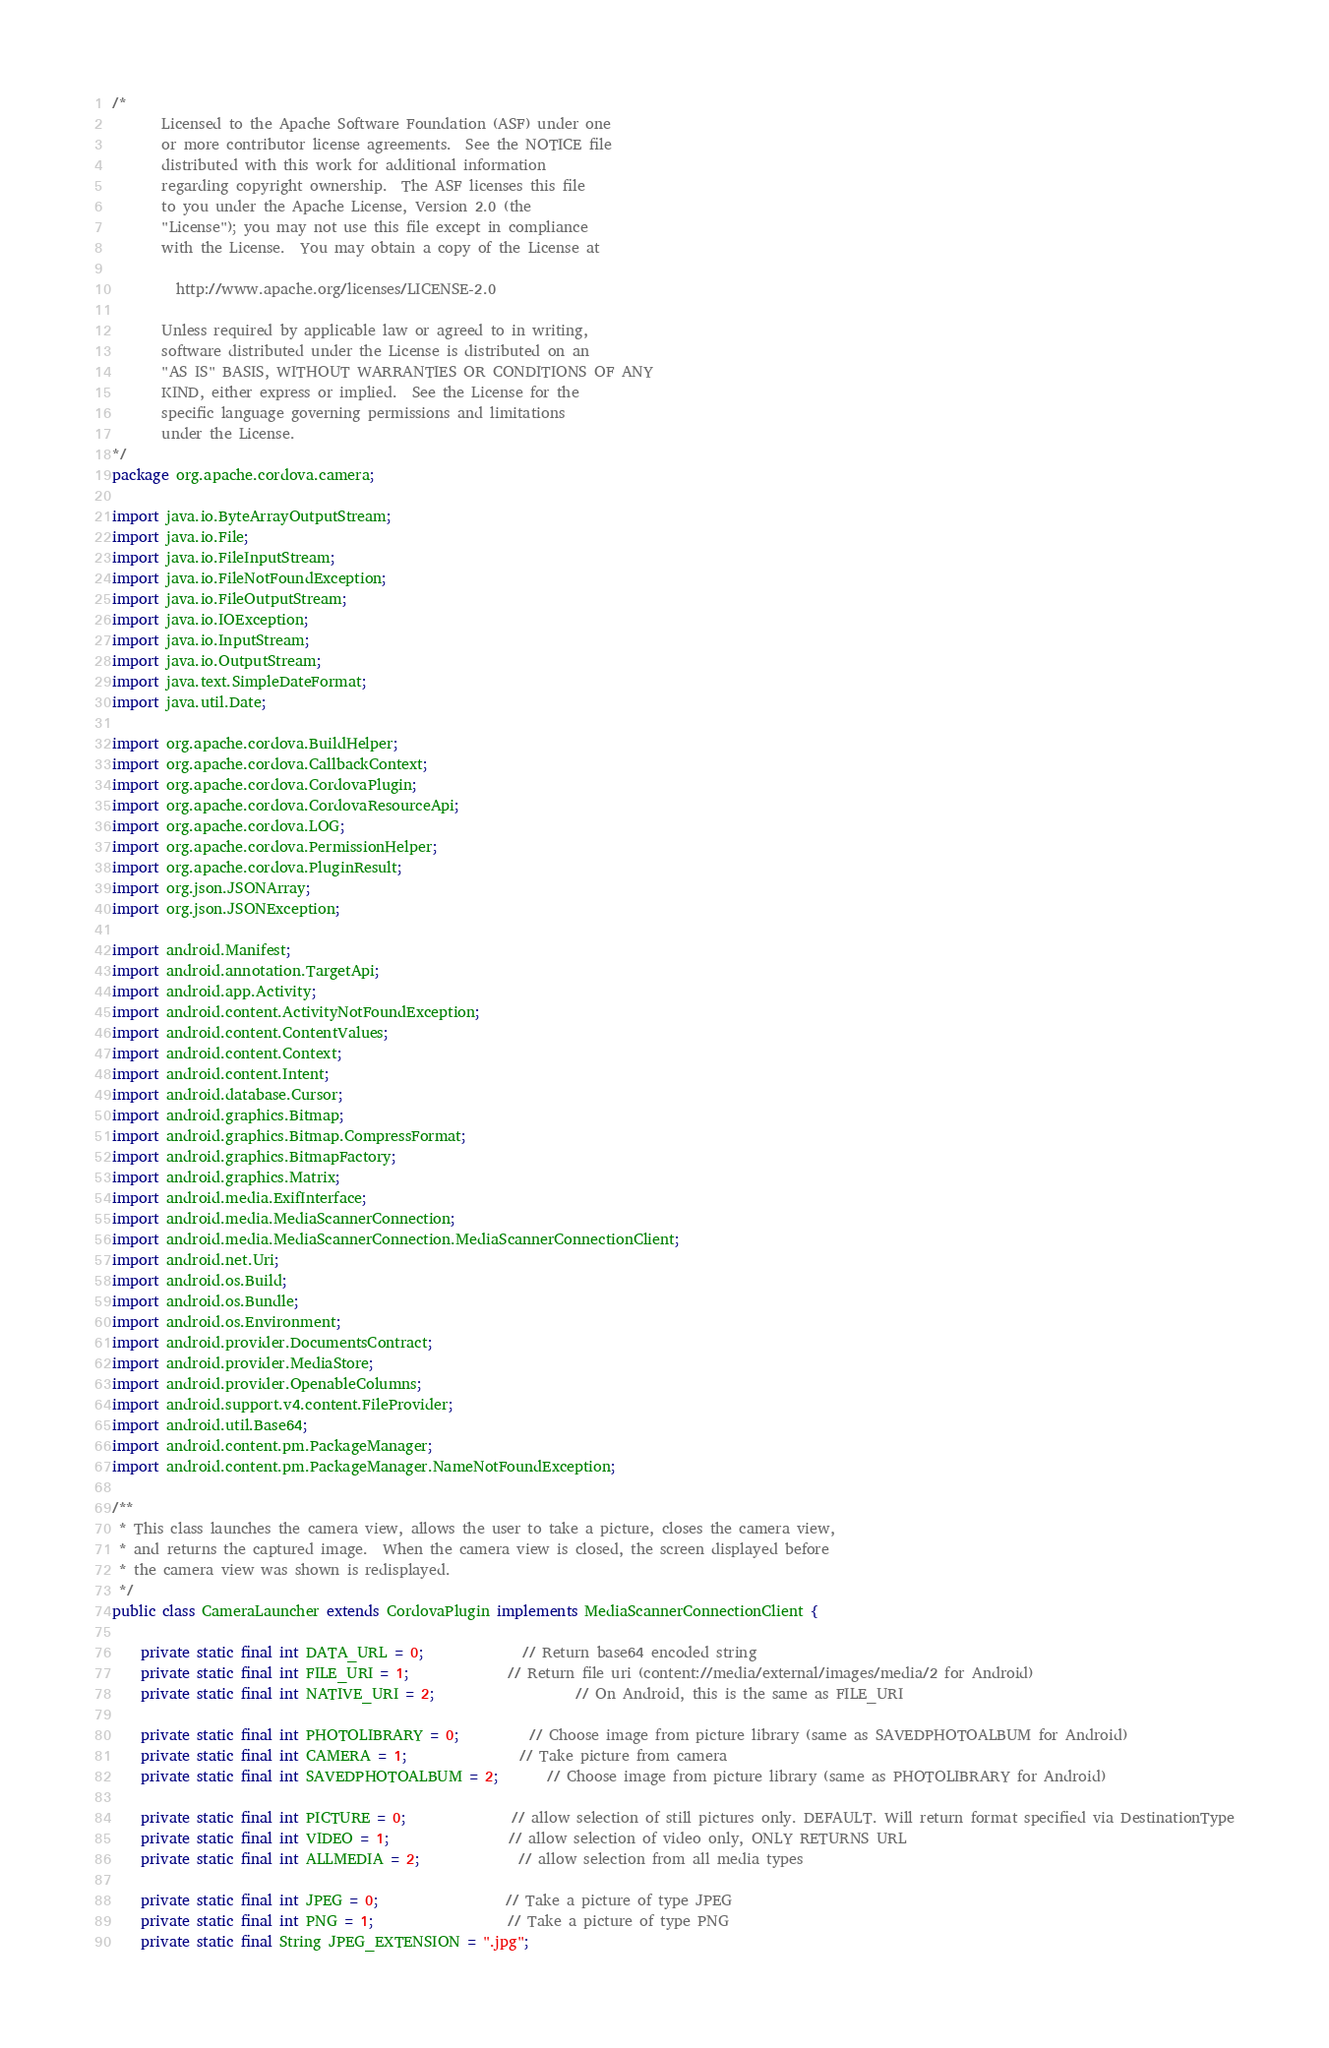Convert code to text. <code><loc_0><loc_0><loc_500><loc_500><_Java_>/*
       Licensed to the Apache Software Foundation (ASF) under one
       or more contributor license agreements.  See the NOTICE file
       distributed with this work for additional information
       regarding copyright ownership.  The ASF licenses this file
       to you under the Apache License, Version 2.0 (the
       "License"); you may not use this file except in compliance
       with the License.  You may obtain a copy of the License at

         http://www.apache.org/licenses/LICENSE-2.0

       Unless required by applicable law or agreed to in writing,
       software distributed under the License is distributed on an
       "AS IS" BASIS, WITHOUT WARRANTIES OR CONDITIONS OF ANY
       KIND, either express or implied.  See the License for the
       specific language governing permissions and limitations
       under the License.
*/
package org.apache.cordova.camera;

import java.io.ByteArrayOutputStream;
import java.io.File;
import java.io.FileInputStream;
import java.io.FileNotFoundException;
import java.io.FileOutputStream;
import java.io.IOException;
import java.io.InputStream;
import java.io.OutputStream;
import java.text.SimpleDateFormat;
import java.util.Date;

import org.apache.cordova.BuildHelper;
import org.apache.cordova.CallbackContext;
import org.apache.cordova.CordovaPlugin;
import org.apache.cordova.CordovaResourceApi;
import org.apache.cordova.LOG;
import org.apache.cordova.PermissionHelper;
import org.apache.cordova.PluginResult;
import org.json.JSONArray;
import org.json.JSONException;

import android.Manifest;
import android.annotation.TargetApi;
import android.app.Activity;
import android.content.ActivityNotFoundException;
import android.content.ContentValues;
import android.content.Context;
import android.content.Intent;
import android.database.Cursor;
import android.graphics.Bitmap;
import android.graphics.Bitmap.CompressFormat;
import android.graphics.BitmapFactory;
import android.graphics.Matrix;
import android.media.ExifInterface;
import android.media.MediaScannerConnection;
import android.media.MediaScannerConnection.MediaScannerConnectionClient;
import android.net.Uri;
import android.os.Build;
import android.os.Bundle;
import android.os.Environment;
import android.provider.DocumentsContract;
import android.provider.MediaStore;
import android.provider.OpenableColumns;
import android.support.v4.content.FileProvider;
import android.util.Base64;
import android.content.pm.PackageManager;
import android.content.pm.PackageManager.NameNotFoundException;

/**
 * This class launches the camera view, allows the user to take a picture, closes the camera view,
 * and returns the captured image.  When the camera view is closed, the screen displayed before
 * the camera view was shown is redisplayed.
 */
public class CameraLauncher extends CordovaPlugin implements MediaScannerConnectionClient {

    private static final int DATA_URL = 0;              // Return base64 encoded string
    private static final int FILE_URI = 1;              // Return file uri (content://media/external/images/media/2 for Android)
    private static final int NATIVE_URI = 2;                    // On Android, this is the same as FILE_URI

    private static final int PHOTOLIBRARY = 0;          // Choose image from picture library (same as SAVEDPHOTOALBUM for Android)
    private static final int CAMERA = 1;                // Take picture from camera
    private static final int SAVEDPHOTOALBUM = 2;       // Choose image from picture library (same as PHOTOLIBRARY for Android)

    private static final int PICTURE = 0;               // allow selection of still pictures only. DEFAULT. Will return format specified via DestinationType
    private static final int VIDEO = 1;                 // allow selection of video only, ONLY RETURNS URL
    private static final int ALLMEDIA = 2;              // allow selection from all media types

    private static final int JPEG = 0;                  // Take a picture of type JPEG
    private static final int PNG = 1;                   // Take a picture of type PNG
    private static final String JPEG_EXTENSION = ".jpg";</code> 